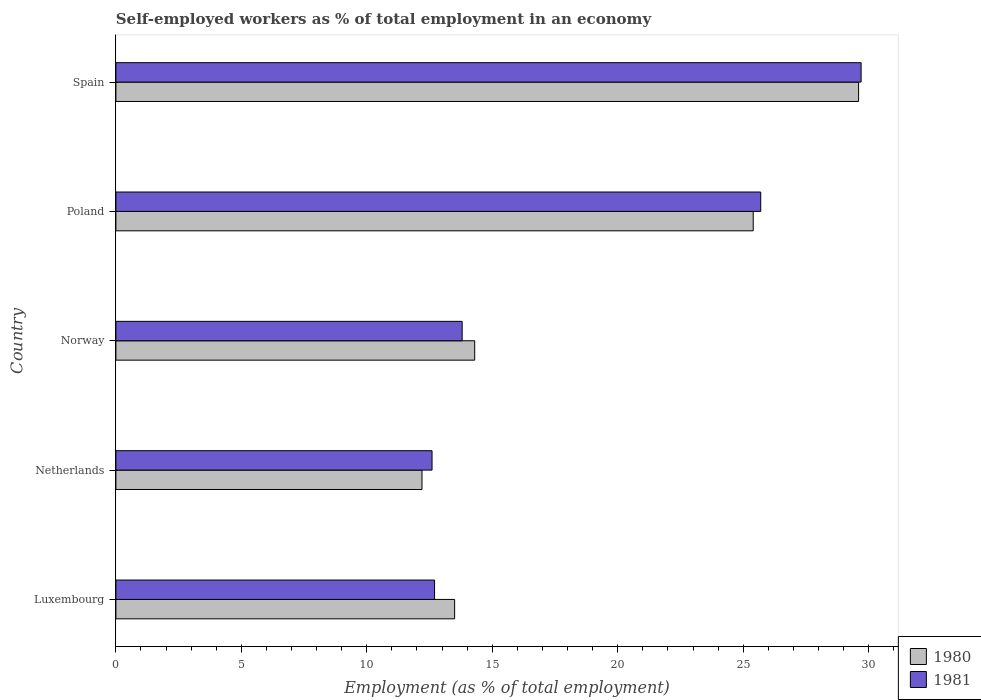How many different coloured bars are there?
Provide a short and direct response. 2. How many groups of bars are there?
Keep it short and to the point. 5. How many bars are there on the 4th tick from the top?
Offer a terse response. 2. How many bars are there on the 3rd tick from the bottom?
Your response must be concise. 2. What is the label of the 2nd group of bars from the top?
Offer a very short reply. Poland. In how many cases, is the number of bars for a given country not equal to the number of legend labels?
Provide a short and direct response. 0. What is the percentage of self-employed workers in 1981 in Poland?
Provide a succinct answer. 25.7. Across all countries, what is the maximum percentage of self-employed workers in 1981?
Offer a terse response. 29.7. Across all countries, what is the minimum percentage of self-employed workers in 1980?
Keep it short and to the point. 12.2. In which country was the percentage of self-employed workers in 1980 maximum?
Keep it short and to the point. Spain. What is the total percentage of self-employed workers in 1981 in the graph?
Your answer should be compact. 94.5. What is the difference between the percentage of self-employed workers in 1980 in Norway and that in Spain?
Make the answer very short. -15.3. What is the difference between the percentage of self-employed workers in 1980 in Luxembourg and the percentage of self-employed workers in 1981 in Norway?
Your response must be concise. -0.3. What is the difference between the percentage of self-employed workers in 1980 and percentage of self-employed workers in 1981 in Poland?
Your answer should be very brief. -0.3. What is the ratio of the percentage of self-employed workers in 1980 in Luxembourg to that in Netherlands?
Your answer should be compact. 1.11. Is the percentage of self-employed workers in 1980 in Netherlands less than that in Spain?
Ensure brevity in your answer.  Yes. Is the difference between the percentage of self-employed workers in 1980 in Netherlands and Spain greater than the difference between the percentage of self-employed workers in 1981 in Netherlands and Spain?
Keep it short and to the point. No. What is the difference between the highest and the second highest percentage of self-employed workers in 1980?
Keep it short and to the point. 4.2. What is the difference between the highest and the lowest percentage of self-employed workers in 1981?
Keep it short and to the point. 17.1. In how many countries, is the percentage of self-employed workers in 1981 greater than the average percentage of self-employed workers in 1981 taken over all countries?
Give a very brief answer. 2. Is the sum of the percentage of self-employed workers in 1981 in Norway and Spain greater than the maximum percentage of self-employed workers in 1980 across all countries?
Ensure brevity in your answer.  Yes. Are all the bars in the graph horizontal?
Offer a very short reply. Yes. What is the difference between two consecutive major ticks on the X-axis?
Give a very brief answer. 5. Does the graph contain grids?
Give a very brief answer. No. Where does the legend appear in the graph?
Your answer should be compact. Bottom right. How are the legend labels stacked?
Provide a short and direct response. Vertical. What is the title of the graph?
Provide a succinct answer. Self-employed workers as % of total employment in an economy. Does "2008" appear as one of the legend labels in the graph?
Your answer should be very brief. No. What is the label or title of the X-axis?
Offer a very short reply. Employment (as % of total employment). What is the Employment (as % of total employment) in 1980 in Luxembourg?
Offer a terse response. 13.5. What is the Employment (as % of total employment) of 1981 in Luxembourg?
Your answer should be very brief. 12.7. What is the Employment (as % of total employment) of 1980 in Netherlands?
Keep it short and to the point. 12.2. What is the Employment (as % of total employment) in 1981 in Netherlands?
Make the answer very short. 12.6. What is the Employment (as % of total employment) in 1980 in Norway?
Provide a succinct answer. 14.3. What is the Employment (as % of total employment) in 1981 in Norway?
Make the answer very short. 13.8. What is the Employment (as % of total employment) in 1980 in Poland?
Provide a short and direct response. 25.4. What is the Employment (as % of total employment) in 1981 in Poland?
Your response must be concise. 25.7. What is the Employment (as % of total employment) of 1980 in Spain?
Your response must be concise. 29.6. What is the Employment (as % of total employment) in 1981 in Spain?
Your response must be concise. 29.7. Across all countries, what is the maximum Employment (as % of total employment) of 1980?
Give a very brief answer. 29.6. Across all countries, what is the maximum Employment (as % of total employment) of 1981?
Make the answer very short. 29.7. Across all countries, what is the minimum Employment (as % of total employment) in 1980?
Keep it short and to the point. 12.2. Across all countries, what is the minimum Employment (as % of total employment) of 1981?
Offer a terse response. 12.6. What is the total Employment (as % of total employment) in 1980 in the graph?
Offer a terse response. 95. What is the total Employment (as % of total employment) of 1981 in the graph?
Provide a short and direct response. 94.5. What is the difference between the Employment (as % of total employment) of 1980 in Luxembourg and that in Netherlands?
Ensure brevity in your answer.  1.3. What is the difference between the Employment (as % of total employment) in 1981 in Luxembourg and that in Netherlands?
Offer a terse response. 0.1. What is the difference between the Employment (as % of total employment) of 1980 in Luxembourg and that in Norway?
Provide a succinct answer. -0.8. What is the difference between the Employment (as % of total employment) of 1980 in Luxembourg and that in Poland?
Provide a succinct answer. -11.9. What is the difference between the Employment (as % of total employment) in 1981 in Luxembourg and that in Poland?
Keep it short and to the point. -13. What is the difference between the Employment (as % of total employment) in 1980 in Luxembourg and that in Spain?
Offer a very short reply. -16.1. What is the difference between the Employment (as % of total employment) in 1980 in Netherlands and that in Norway?
Ensure brevity in your answer.  -2.1. What is the difference between the Employment (as % of total employment) of 1980 in Netherlands and that in Spain?
Your response must be concise. -17.4. What is the difference between the Employment (as % of total employment) in 1981 in Netherlands and that in Spain?
Provide a succinct answer. -17.1. What is the difference between the Employment (as % of total employment) of 1980 in Norway and that in Spain?
Offer a terse response. -15.3. What is the difference between the Employment (as % of total employment) of 1981 in Norway and that in Spain?
Keep it short and to the point. -15.9. What is the difference between the Employment (as % of total employment) of 1981 in Poland and that in Spain?
Provide a short and direct response. -4. What is the difference between the Employment (as % of total employment) in 1980 in Luxembourg and the Employment (as % of total employment) in 1981 in Poland?
Provide a succinct answer. -12.2. What is the difference between the Employment (as % of total employment) of 1980 in Luxembourg and the Employment (as % of total employment) of 1981 in Spain?
Your answer should be very brief. -16.2. What is the difference between the Employment (as % of total employment) in 1980 in Netherlands and the Employment (as % of total employment) in 1981 in Spain?
Keep it short and to the point. -17.5. What is the difference between the Employment (as % of total employment) of 1980 in Norway and the Employment (as % of total employment) of 1981 in Spain?
Offer a terse response. -15.4. What is the average Employment (as % of total employment) in 1980 per country?
Give a very brief answer. 19. What is the average Employment (as % of total employment) in 1981 per country?
Give a very brief answer. 18.9. What is the difference between the Employment (as % of total employment) of 1980 and Employment (as % of total employment) of 1981 in Netherlands?
Keep it short and to the point. -0.4. What is the ratio of the Employment (as % of total employment) in 1980 in Luxembourg to that in Netherlands?
Your answer should be very brief. 1.11. What is the ratio of the Employment (as % of total employment) in 1981 in Luxembourg to that in Netherlands?
Your response must be concise. 1.01. What is the ratio of the Employment (as % of total employment) in 1980 in Luxembourg to that in Norway?
Ensure brevity in your answer.  0.94. What is the ratio of the Employment (as % of total employment) of 1981 in Luxembourg to that in Norway?
Ensure brevity in your answer.  0.92. What is the ratio of the Employment (as % of total employment) in 1980 in Luxembourg to that in Poland?
Your answer should be compact. 0.53. What is the ratio of the Employment (as % of total employment) in 1981 in Luxembourg to that in Poland?
Provide a succinct answer. 0.49. What is the ratio of the Employment (as % of total employment) in 1980 in Luxembourg to that in Spain?
Ensure brevity in your answer.  0.46. What is the ratio of the Employment (as % of total employment) of 1981 in Luxembourg to that in Spain?
Keep it short and to the point. 0.43. What is the ratio of the Employment (as % of total employment) of 1980 in Netherlands to that in Norway?
Offer a terse response. 0.85. What is the ratio of the Employment (as % of total employment) of 1981 in Netherlands to that in Norway?
Your answer should be compact. 0.91. What is the ratio of the Employment (as % of total employment) in 1980 in Netherlands to that in Poland?
Provide a succinct answer. 0.48. What is the ratio of the Employment (as % of total employment) of 1981 in Netherlands to that in Poland?
Your response must be concise. 0.49. What is the ratio of the Employment (as % of total employment) of 1980 in Netherlands to that in Spain?
Your answer should be very brief. 0.41. What is the ratio of the Employment (as % of total employment) of 1981 in Netherlands to that in Spain?
Your answer should be very brief. 0.42. What is the ratio of the Employment (as % of total employment) in 1980 in Norway to that in Poland?
Offer a terse response. 0.56. What is the ratio of the Employment (as % of total employment) in 1981 in Norway to that in Poland?
Give a very brief answer. 0.54. What is the ratio of the Employment (as % of total employment) in 1980 in Norway to that in Spain?
Provide a short and direct response. 0.48. What is the ratio of the Employment (as % of total employment) in 1981 in Norway to that in Spain?
Provide a succinct answer. 0.46. What is the ratio of the Employment (as % of total employment) of 1980 in Poland to that in Spain?
Provide a short and direct response. 0.86. What is the ratio of the Employment (as % of total employment) of 1981 in Poland to that in Spain?
Your response must be concise. 0.87. What is the difference between the highest and the lowest Employment (as % of total employment) of 1980?
Offer a very short reply. 17.4. 